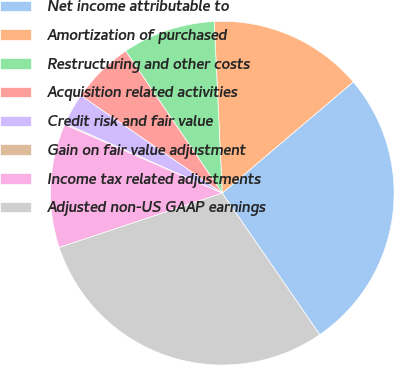Convert chart to OTSL. <chart><loc_0><loc_0><loc_500><loc_500><pie_chart><fcel>Net income attributable to<fcel>Amortization of purchased<fcel>Restructuring and other costs<fcel>Acquisition related activities<fcel>Credit risk and fair value<fcel>Gain on fair value adjustment<fcel>Income tax related adjustments<fcel>Adjusted non-US GAAP earnings<nl><fcel>26.6%<fcel>14.54%<fcel>8.76%<fcel>5.88%<fcel>2.99%<fcel>0.1%<fcel>11.65%<fcel>29.48%<nl></chart> 